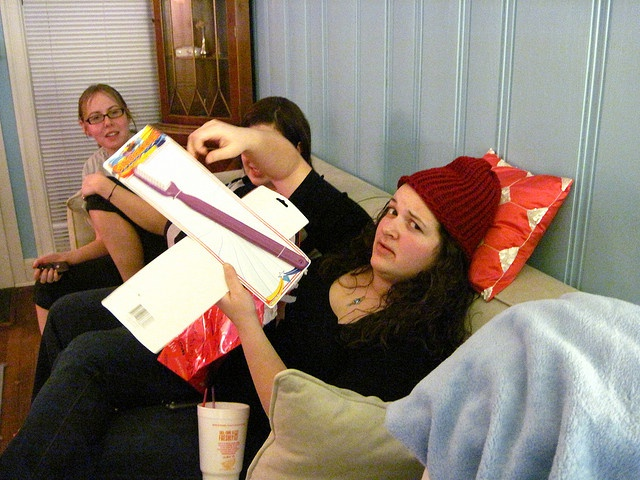Describe the objects in this image and their specific colors. I can see people in lightgray, black, maroon, tan, and salmon tones, people in lightgray, black, salmon, and brown tones, people in lightgray, black, maroon, tan, and brown tones, couch in lightgray, tan, gray, and olive tones, and cup in lightgray and tan tones in this image. 